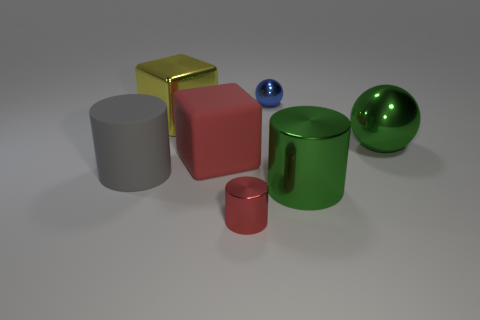Subtract all big green shiny cylinders. How many cylinders are left? 2 Add 2 gray matte cylinders. How many objects exist? 9 Subtract all gray cylinders. How many cylinders are left? 2 Add 4 big gray objects. How many big gray objects are left? 5 Add 5 small green shiny cylinders. How many small green shiny cylinders exist? 5 Subtract 0 purple cubes. How many objects are left? 7 Subtract all cubes. How many objects are left? 5 Subtract 3 cylinders. How many cylinders are left? 0 Subtract all cyan balls. Subtract all brown blocks. How many balls are left? 2 Subtract all blue cubes. How many brown spheres are left? 0 